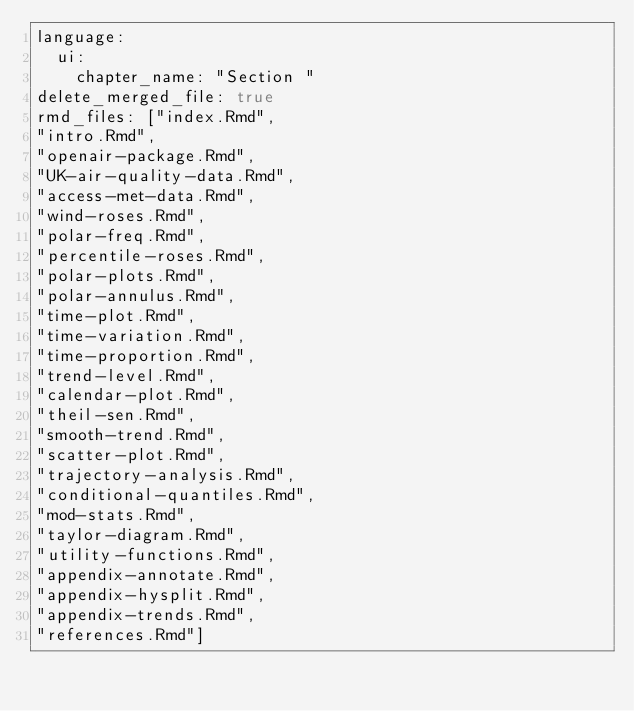<code> <loc_0><loc_0><loc_500><loc_500><_YAML_>language:
  ui:
    chapter_name: "Section "
delete_merged_file: true
rmd_files: ["index.Rmd", 
"intro.Rmd",
"openair-package.Rmd",
"UK-air-quality-data.Rmd",
"access-met-data.Rmd",
"wind-roses.Rmd",
"polar-freq.Rmd",
"percentile-roses.Rmd",
"polar-plots.Rmd",
"polar-annulus.Rmd",
"time-plot.Rmd",
"time-variation.Rmd",
"time-proportion.Rmd",
"trend-level.Rmd",
"calendar-plot.Rmd",
"theil-sen.Rmd",
"smooth-trend.Rmd",
"scatter-plot.Rmd",
"trajectory-analysis.Rmd",
"conditional-quantiles.Rmd",
"mod-stats.Rmd",
"taylor-diagram.Rmd",
"utility-functions.Rmd",
"appendix-annotate.Rmd",
"appendix-hysplit.Rmd",
"appendix-trends.Rmd",
"references.Rmd"]</code> 